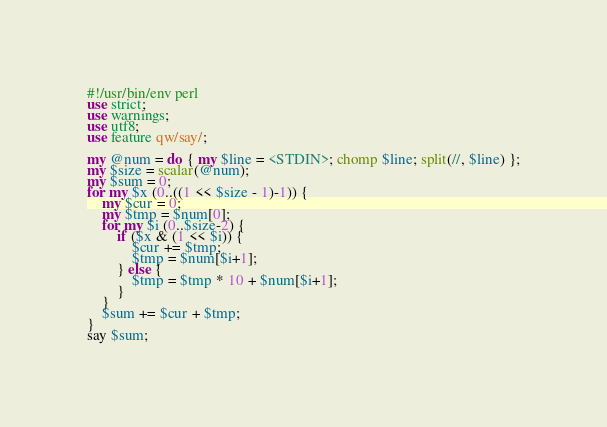<code> <loc_0><loc_0><loc_500><loc_500><_Perl_>#!/usr/bin/env perl
use strict;
use warnings;
use utf8;
use feature qw/say/;

my @num = do { my $line = <STDIN>; chomp $line; split(//, $line) };
my $size = scalar(@num);
my $sum = 0;
for my $x (0..((1 << $size - 1)-1)) {
    my $cur = 0;
    my $tmp = $num[0];
    for my $i (0..$size-2) {
        if ($x & (1 << $i)) {
            $cur += $tmp;
            $tmp = $num[$i+1];
        } else {
            $tmp = $tmp * 10 + $num[$i+1];
        }
    }
    $sum += $cur + $tmp;
}
say $sum;</code> 